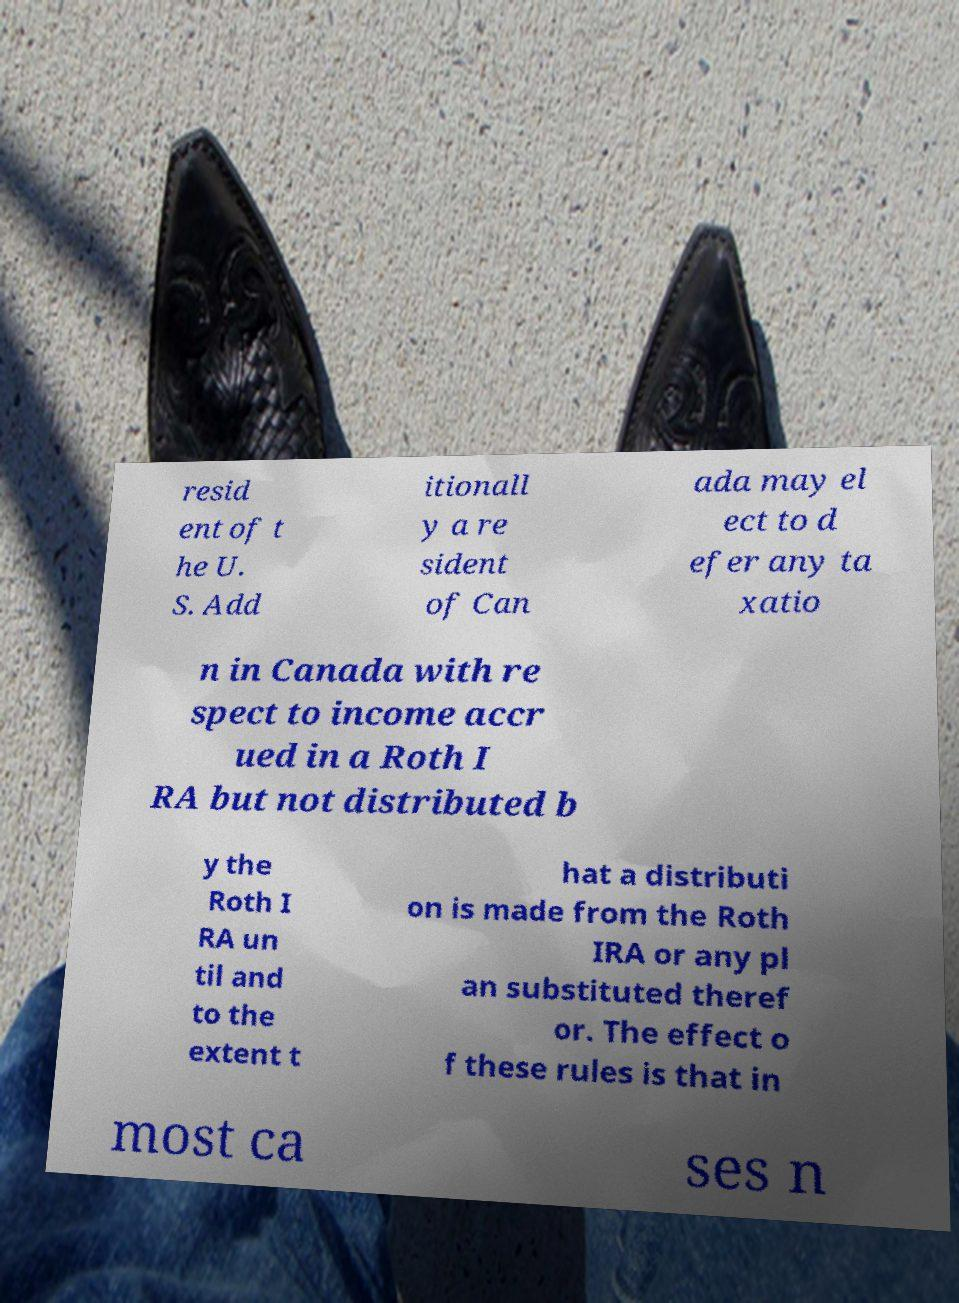Please identify and transcribe the text found in this image. resid ent of t he U. S. Add itionall y a re sident of Can ada may el ect to d efer any ta xatio n in Canada with re spect to income accr ued in a Roth I RA but not distributed b y the Roth I RA un til and to the extent t hat a distributi on is made from the Roth IRA or any pl an substituted theref or. The effect o f these rules is that in most ca ses n 